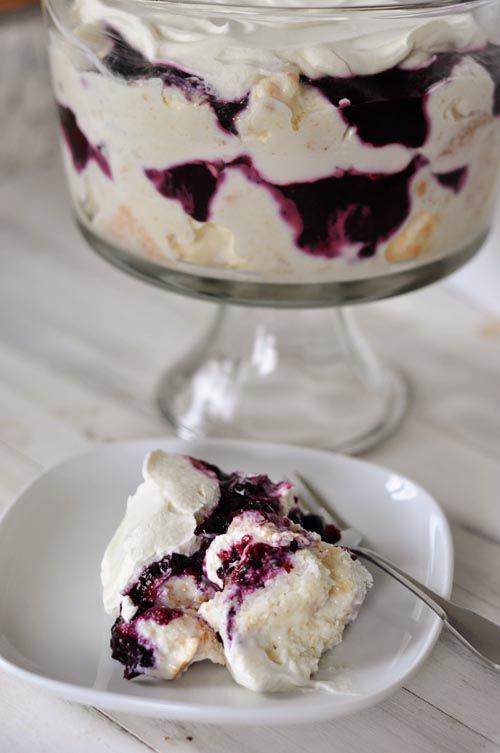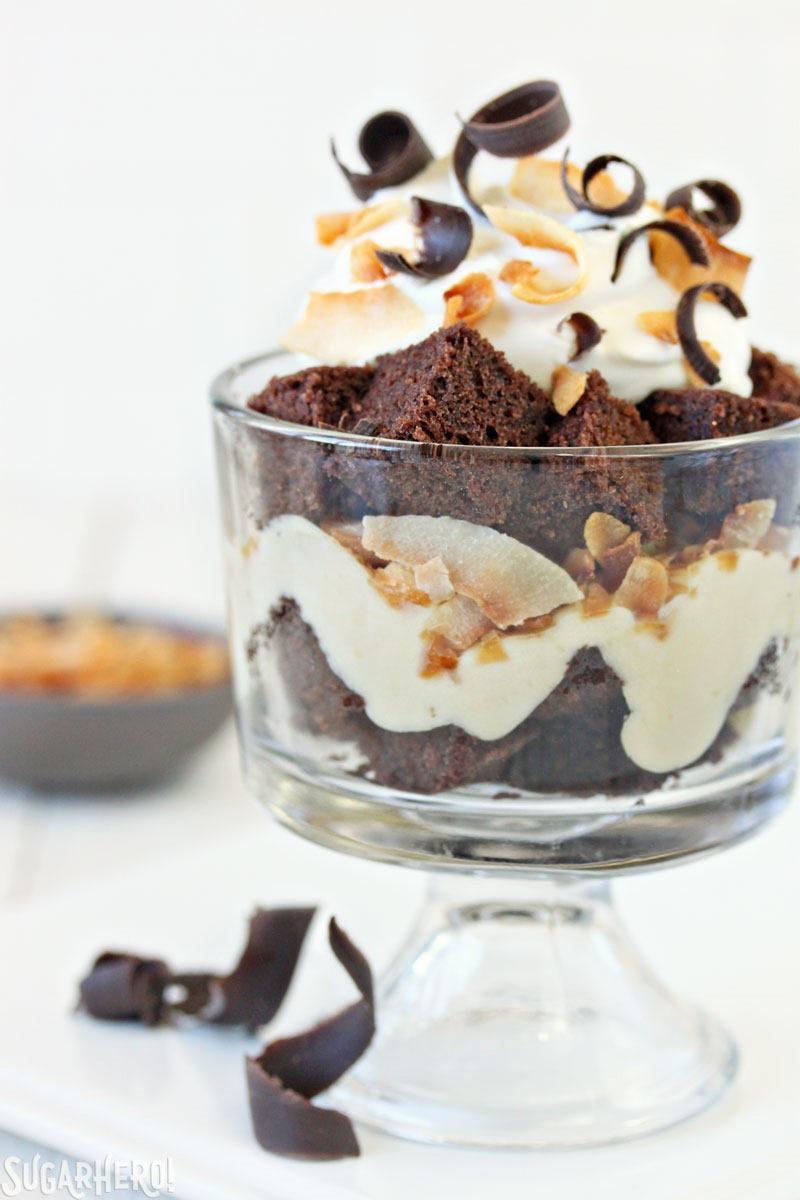The first image is the image on the left, the second image is the image on the right. Analyze the images presented: Is the assertion "Two large chocolate desserts have multiple chocolate and white layers, with sprinkles in the top white layer." valid? Answer yes or no. No. 